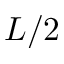Convert formula to latex. <formula><loc_0><loc_0><loc_500><loc_500>L / 2</formula> 